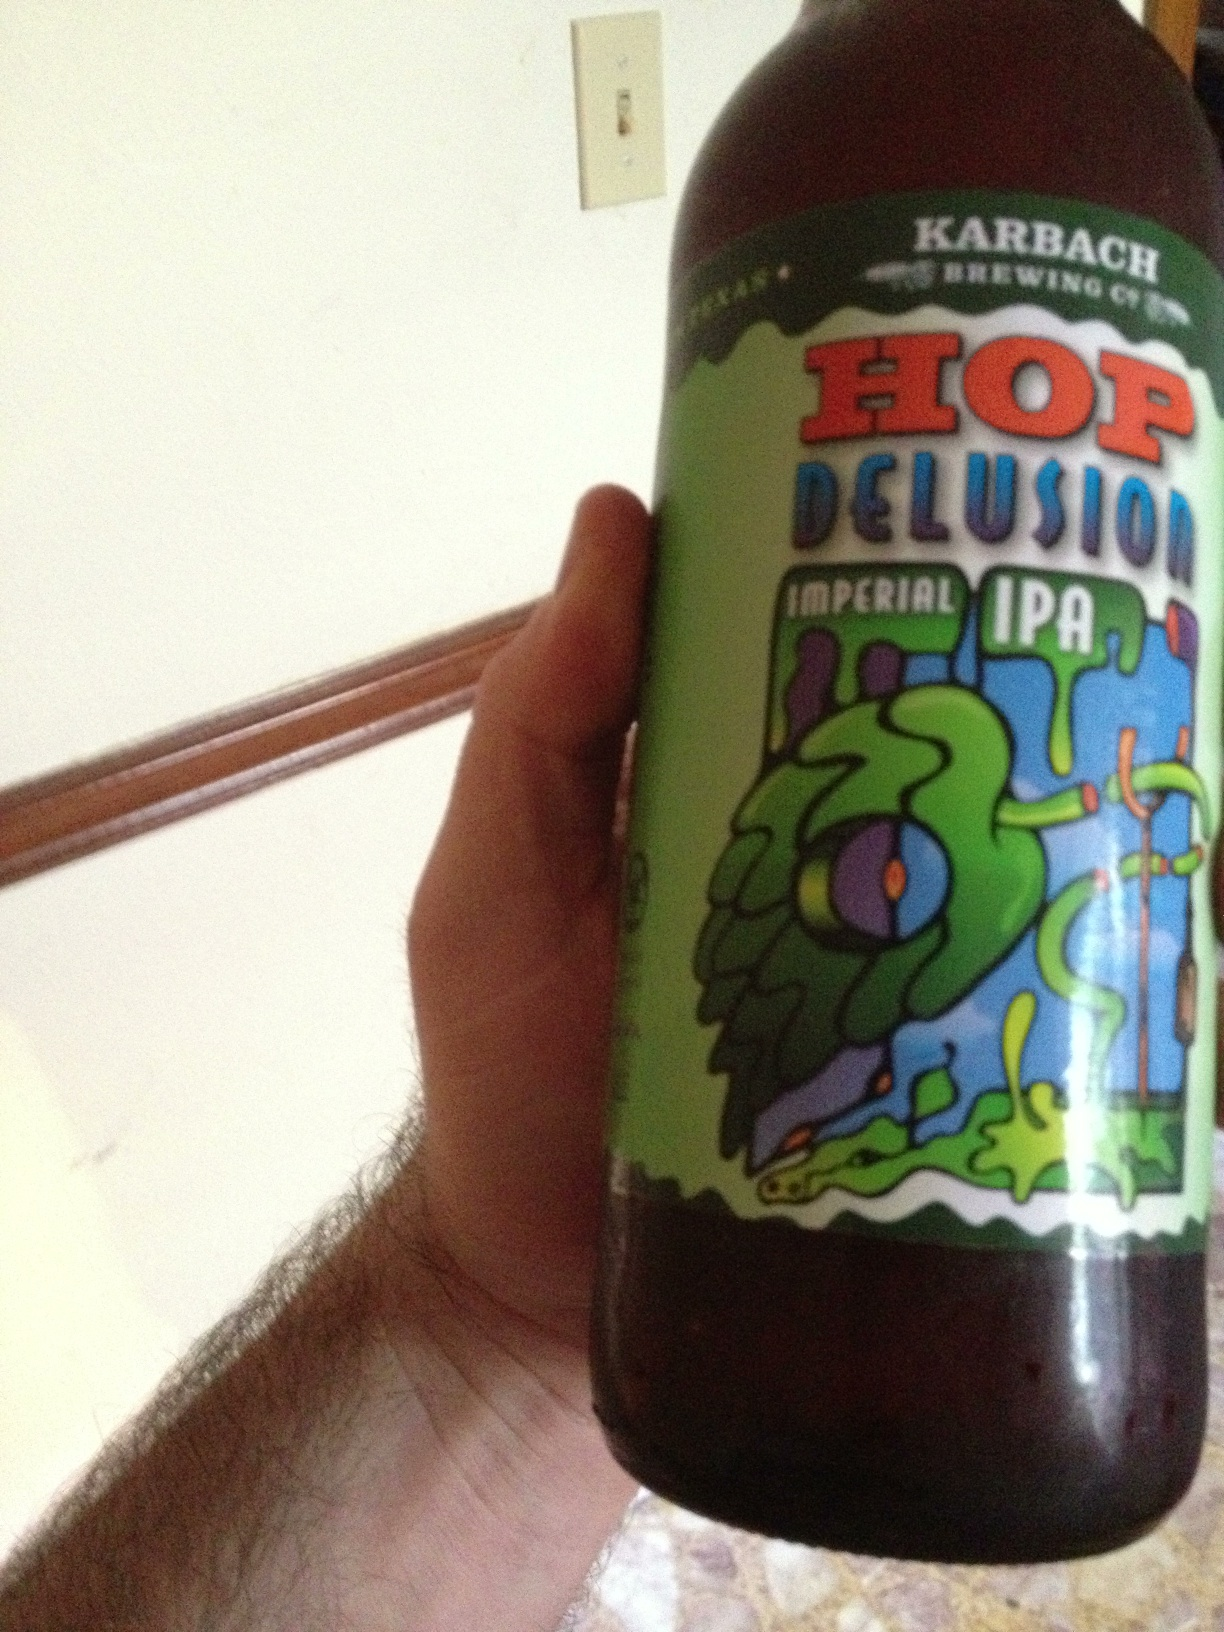What style of beer is this and what brand? The beer in the image is an Imperial IPA, and the brand is Karbach Brewing Co.'s Hop Delusion. Imperial IPAs are known for their strong hop flavors and higher alcohol content, offering a bold and intense taste experience. 